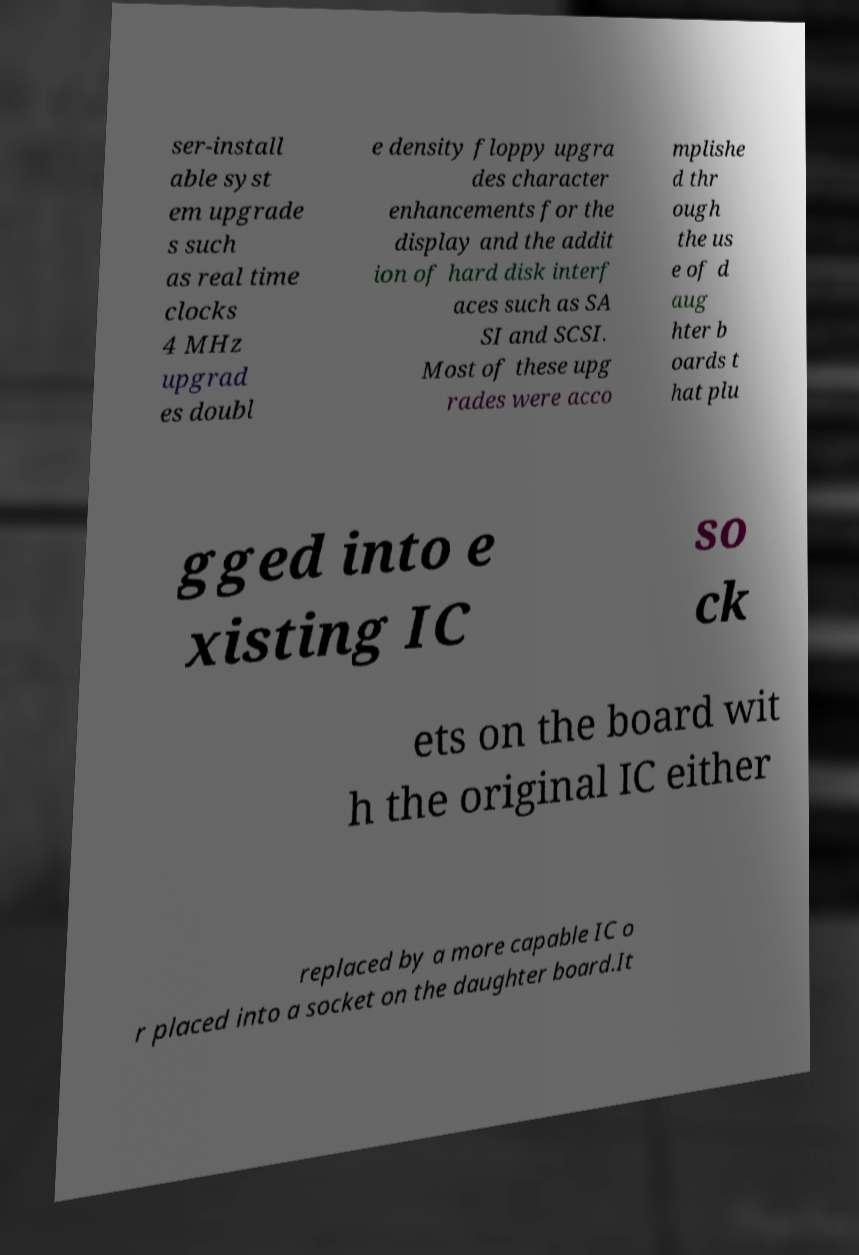Can you accurately transcribe the text from the provided image for me? ser-install able syst em upgrade s such as real time clocks 4 MHz upgrad es doubl e density floppy upgra des character enhancements for the display and the addit ion of hard disk interf aces such as SA SI and SCSI. Most of these upg rades were acco mplishe d thr ough the us e of d aug hter b oards t hat plu gged into e xisting IC so ck ets on the board wit h the original IC either replaced by a more capable IC o r placed into a socket on the daughter board.It 